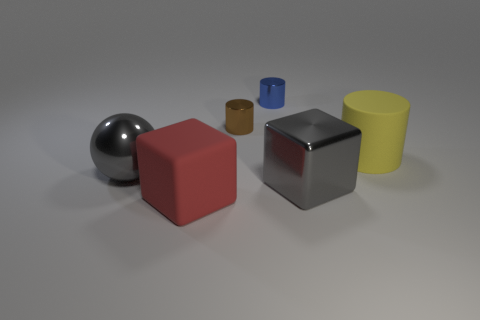What number of big yellow cylinders are in front of the large gray thing on the right side of the blue metallic cylinder?
Make the answer very short. 0. What number of other objects are there of the same size as the red matte thing?
Ensure brevity in your answer.  3. Do the gray metal thing that is on the right side of the brown metal cylinder and the big red rubber thing have the same shape?
Give a very brief answer. Yes. What is the material of the gray thing right of the gray sphere?
Ensure brevity in your answer.  Metal. There is a large shiny thing that is the same color as the big metallic ball; what is its shape?
Your answer should be very brief. Cube. Are there any big gray balls that have the same material as the large yellow cylinder?
Give a very brief answer. No. How big is the brown object?
Give a very brief answer. Small. How many brown objects are large balls or matte things?
Offer a terse response. 0. How many other large yellow rubber objects are the same shape as the yellow matte thing?
Your response must be concise. 0. What number of blue objects are the same size as the yellow matte object?
Give a very brief answer. 0. 